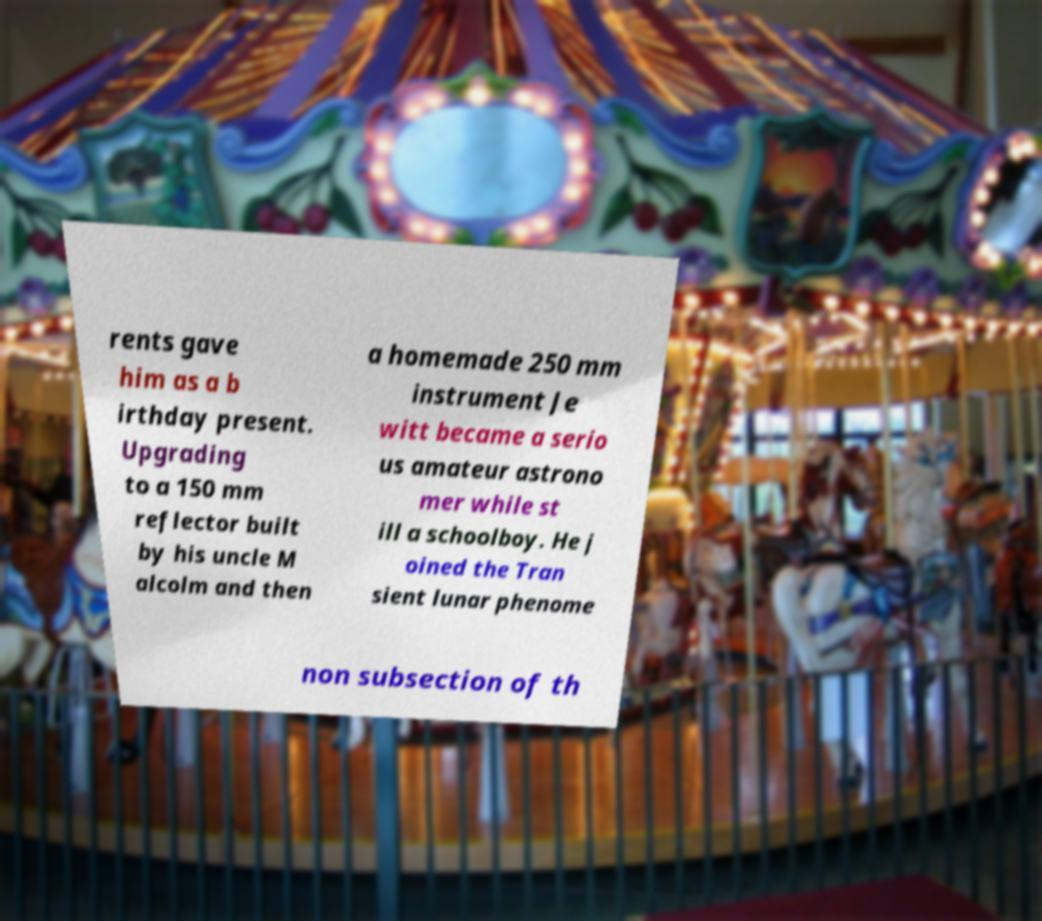Could you assist in decoding the text presented in this image and type it out clearly? rents gave him as a b irthday present. Upgrading to a 150 mm reflector built by his uncle M alcolm and then a homemade 250 mm instrument Je witt became a serio us amateur astrono mer while st ill a schoolboy. He j oined the Tran sient lunar phenome non subsection of th 